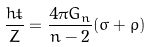Convert formula to latex. <formula><loc_0><loc_0><loc_500><loc_500>\frac { h \dot { t } } { Z } = \frac { 4 \pi G _ { n } } { n - 2 } ( \sigma + \rho )</formula> 